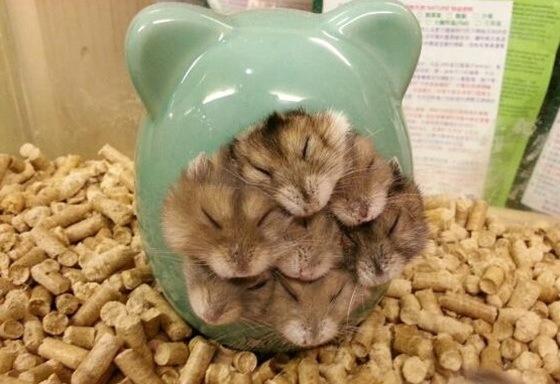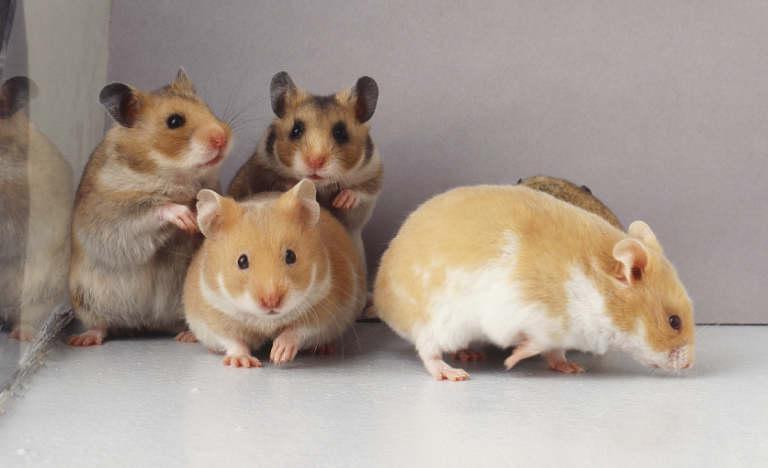The first image is the image on the left, the second image is the image on the right. Assess this claim about the two images: "One of the images shows hamsters crowded inside a container that has ears on top of it.". Correct or not? Answer yes or no. Yes. 